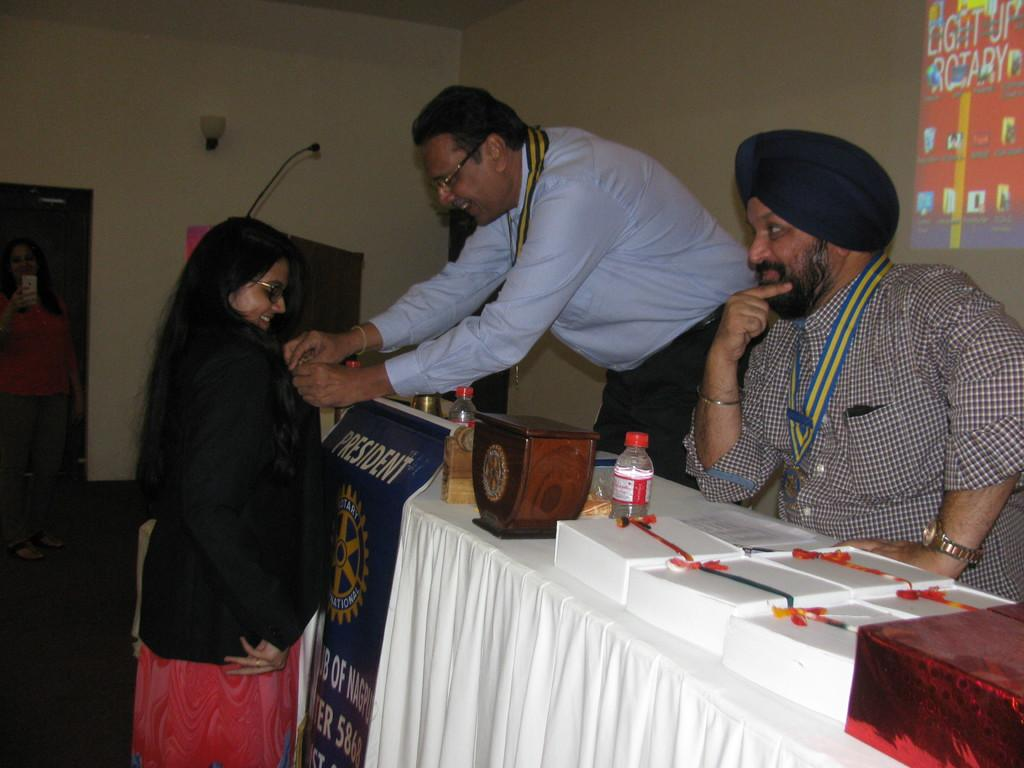<image>
Present a compact description of the photo's key features. A man standing behind a podium for the president of the Rotary International pins an award to a woman's lapel. 